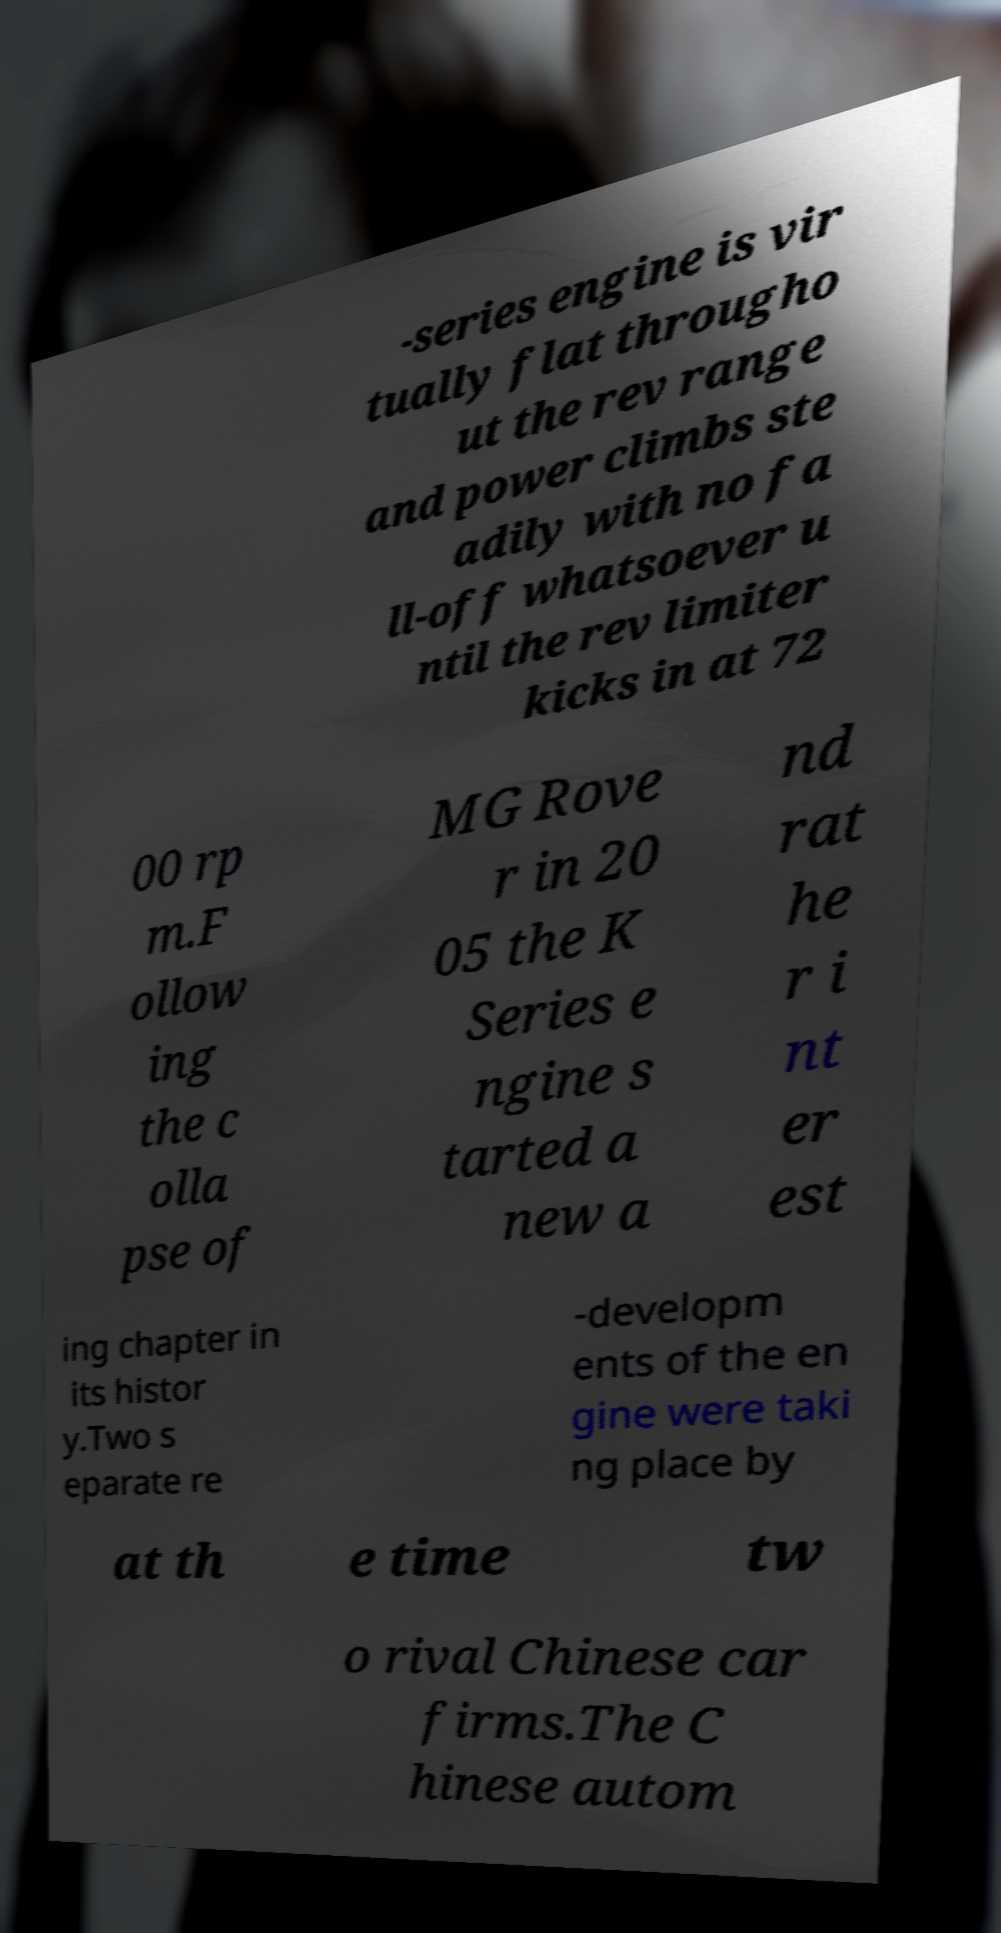Could you assist in decoding the text presented in this image and type it out clearly? -series engine is vir tually flat througho ut the rev range and power climbs ste adily with no fa ll-off whatsoever u ntil the rev limiter kicks in at 72 00 rp m.F ollow ing the c olla pse of MG Rove r in 20 05 the K Series e ngine s tarted a new a nd rat he r i nt er est ing chapter in its histor y.Two s eparate re -developm ents of the en gine were taki ng place by at th e time tw o rival Chinese car firms.The C hinese autom 